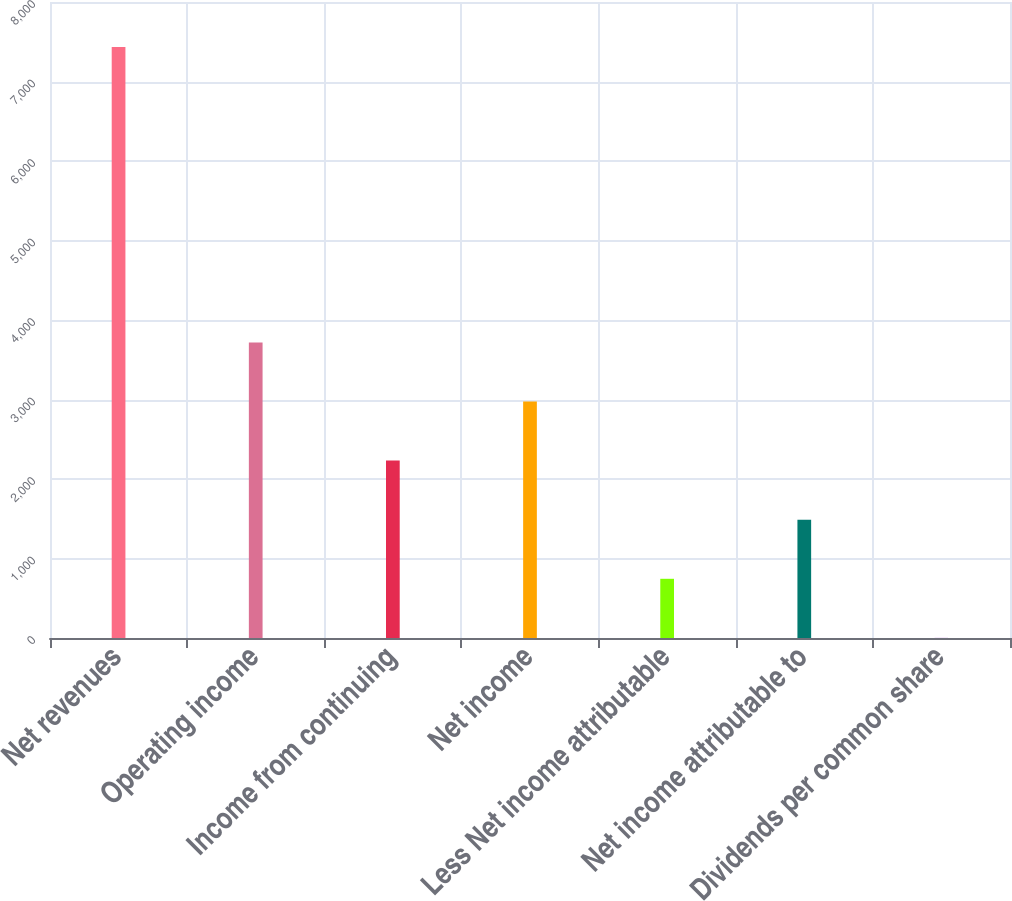<chart> <loc_0><loc_0><loc_500><loc_500><bar_chart><fcel>Net revenues<fcel>Operating income<fcel>Income from continuing<fcel>Net income<fcel>Less Net income attributable<fcel>Net income attributable to<fcel>Dividends per common share<nl><fcel>7435<fcel>3718.17<fcel>2231.43<fcel>2974.8<fcel>744.69<fcel>1488.06<fcel>1.32<nl></chart> 